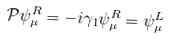Convert formula to latex. <formula><loc_0><loc_0><loc_500><loc_500>\mathcal { P } \psi ^ { R } _ { \mu } = - i \gamma _ { 1 } \psi ^ { R } _ { \mu } = \psi ^ { L } _ { \mu }</formula> 